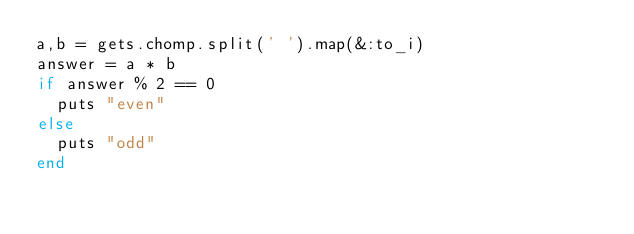Convert code to text. <code><loc_0><loc_0><loc_500><loc_500><_Ruby_>a,b = gets.chomp.split(' ').map(&:to_i)
answer = a * b
if answer % 2 == 0 
  puts "even"
else
  puts "odd"
end</code> 